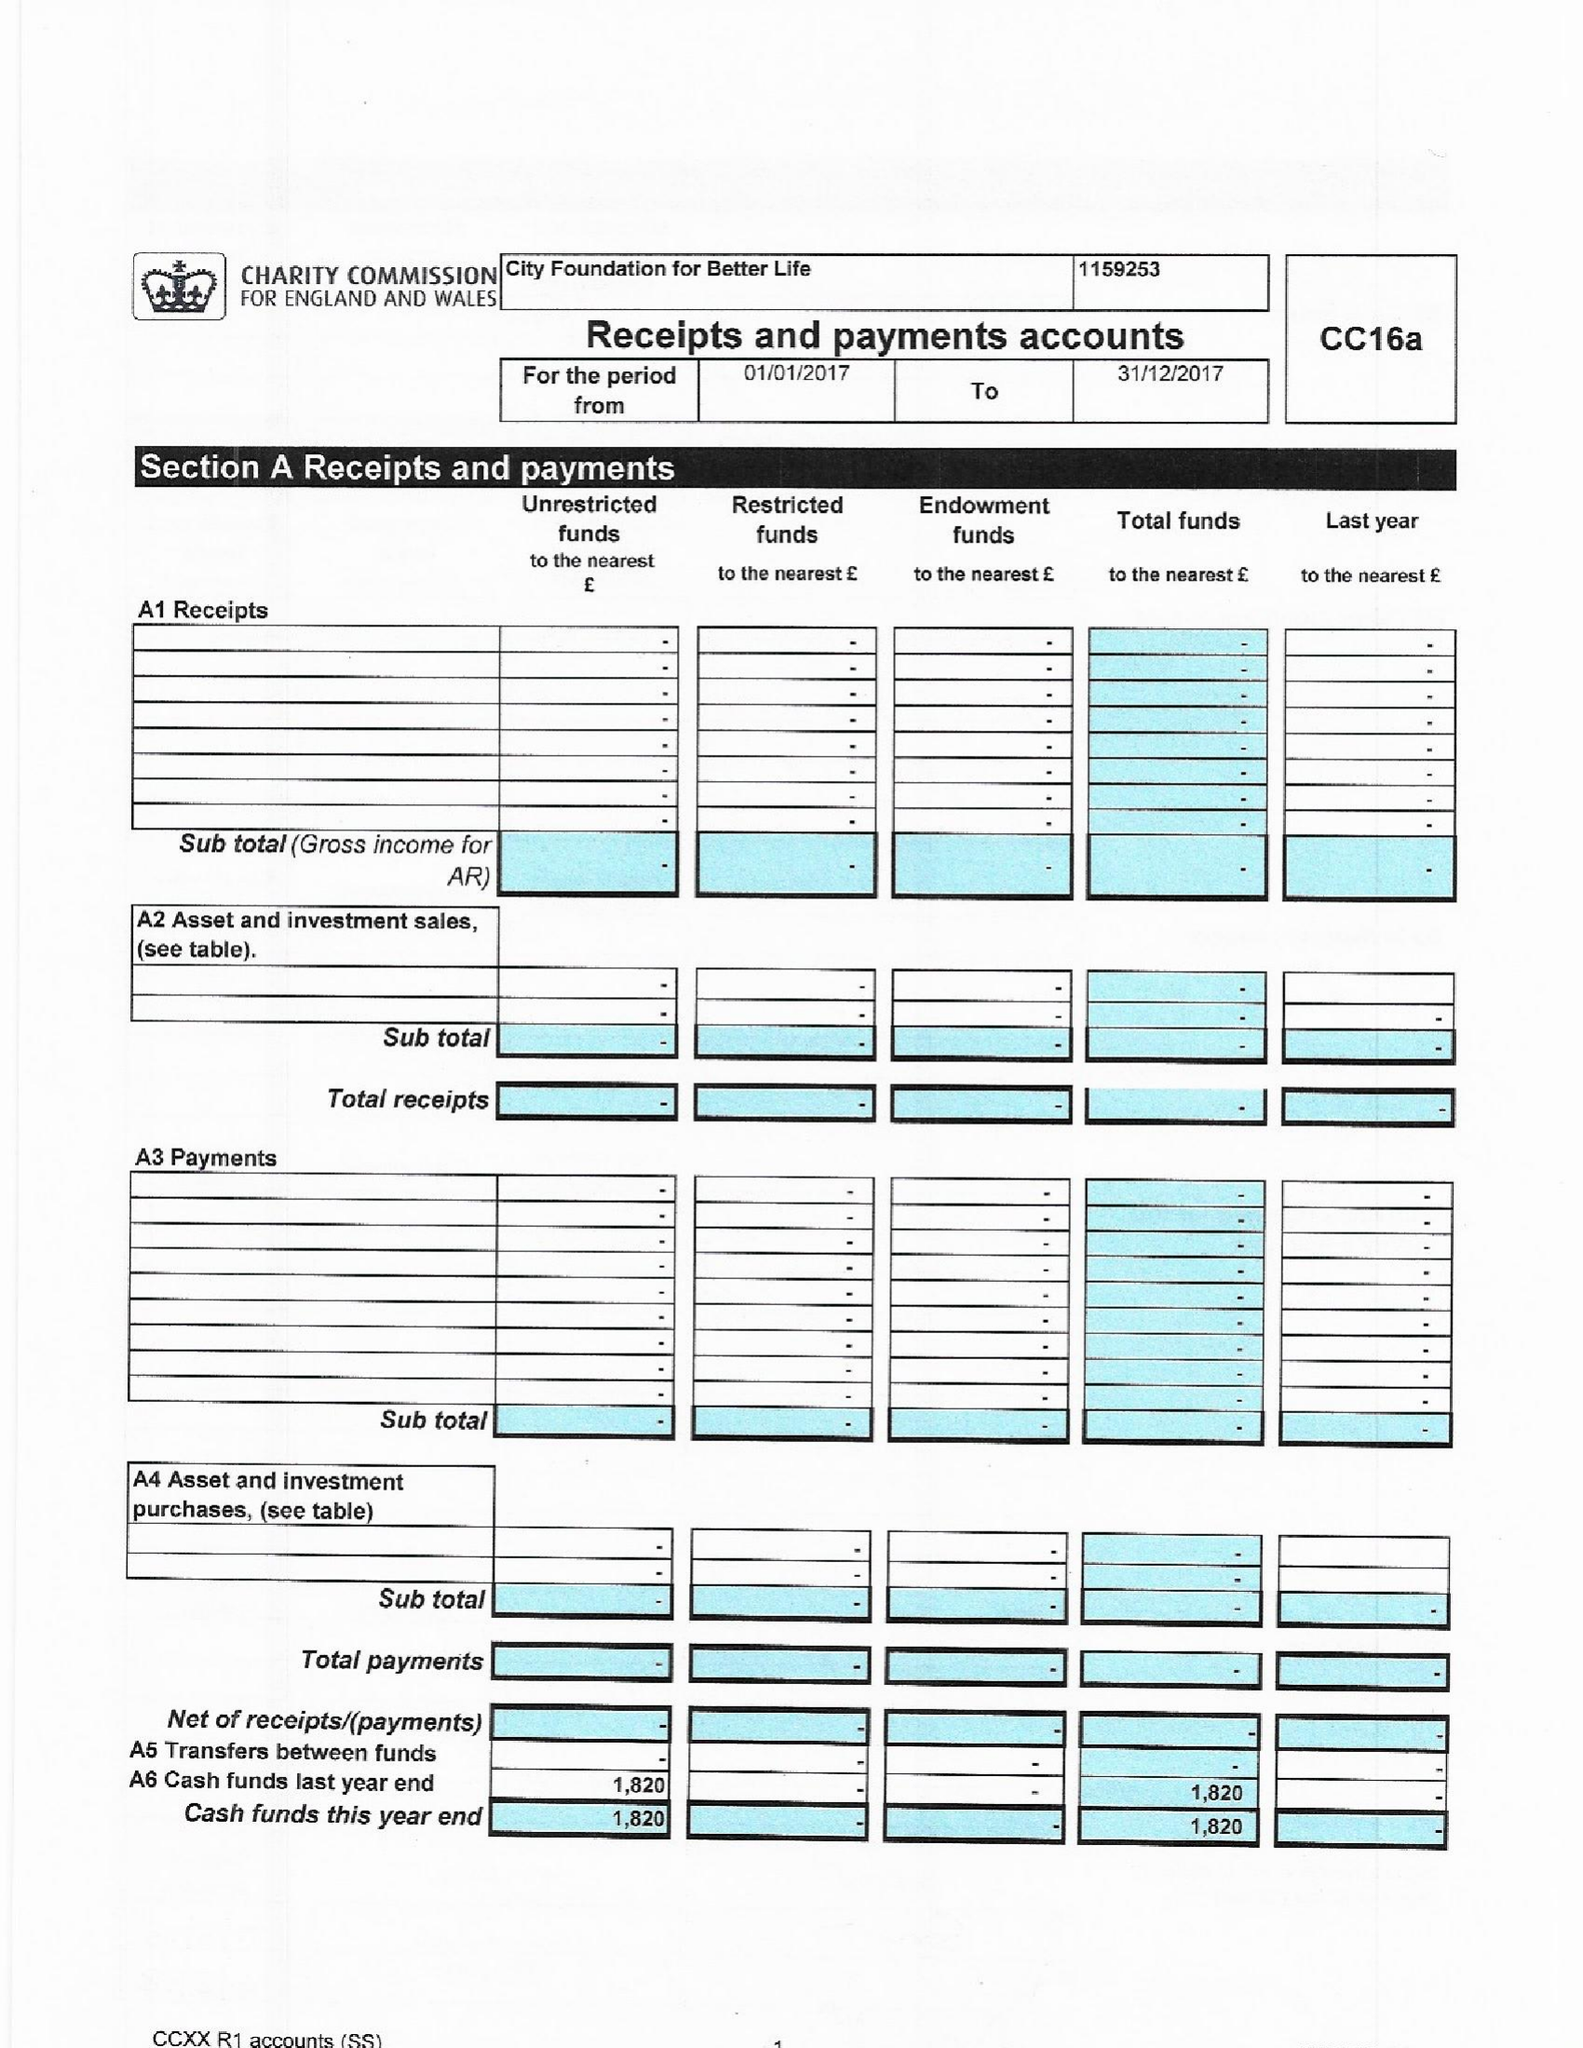What is the value for the address__post_town?
Answer the question using a single word or phrase. NEW MALDEN 